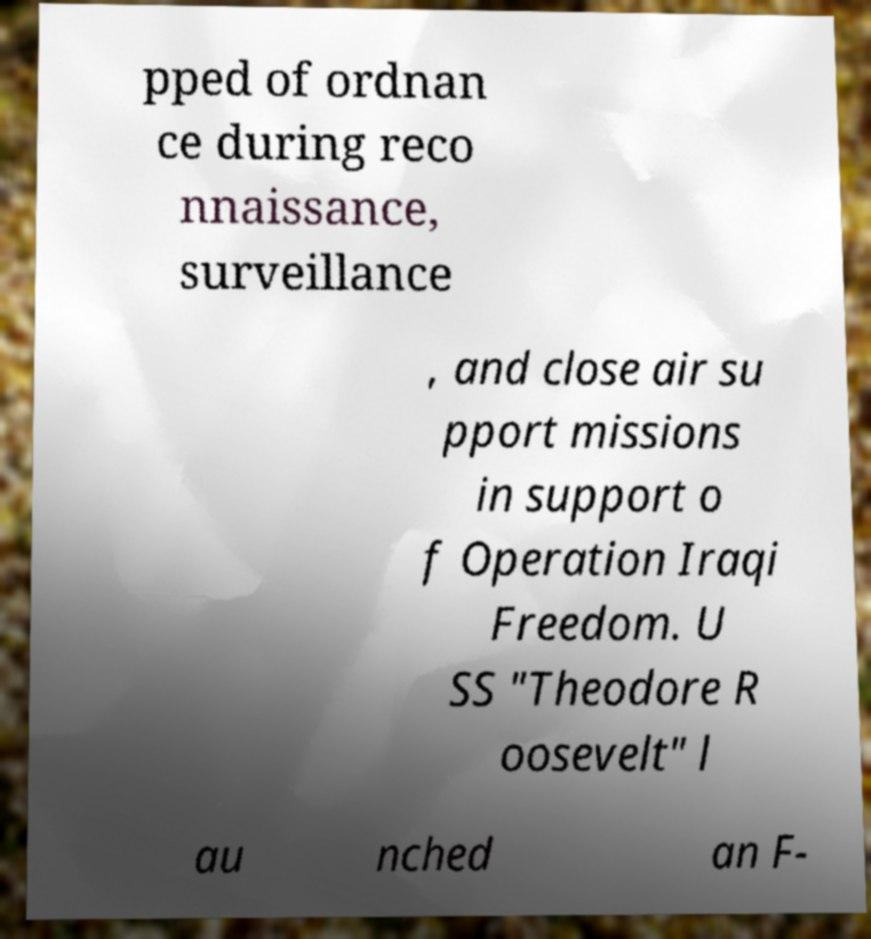Could you assist in decoding the text presented in this image and type it out clearly? pped of ordnan ce during reco nnaissance, surveillance , and close air su pport missions in support o f Operation Iraqi Freedom. U SS "Theodore R oosevelt" l au nched an F- 